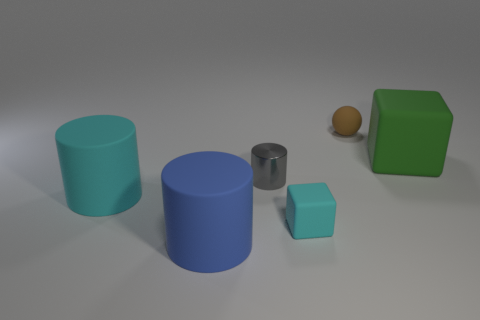Could you create a story based on the arrangement of these objects? Certainly! Upon deep observation, the ordered objects seem to represent a small, abstract civilization on an exoplanet, with the different sizes and shapes signifying structures with varying purposes - cylinders as livable towers, cubes as community centers, and the sphere akin to a central energy source that powers the entire colony. 